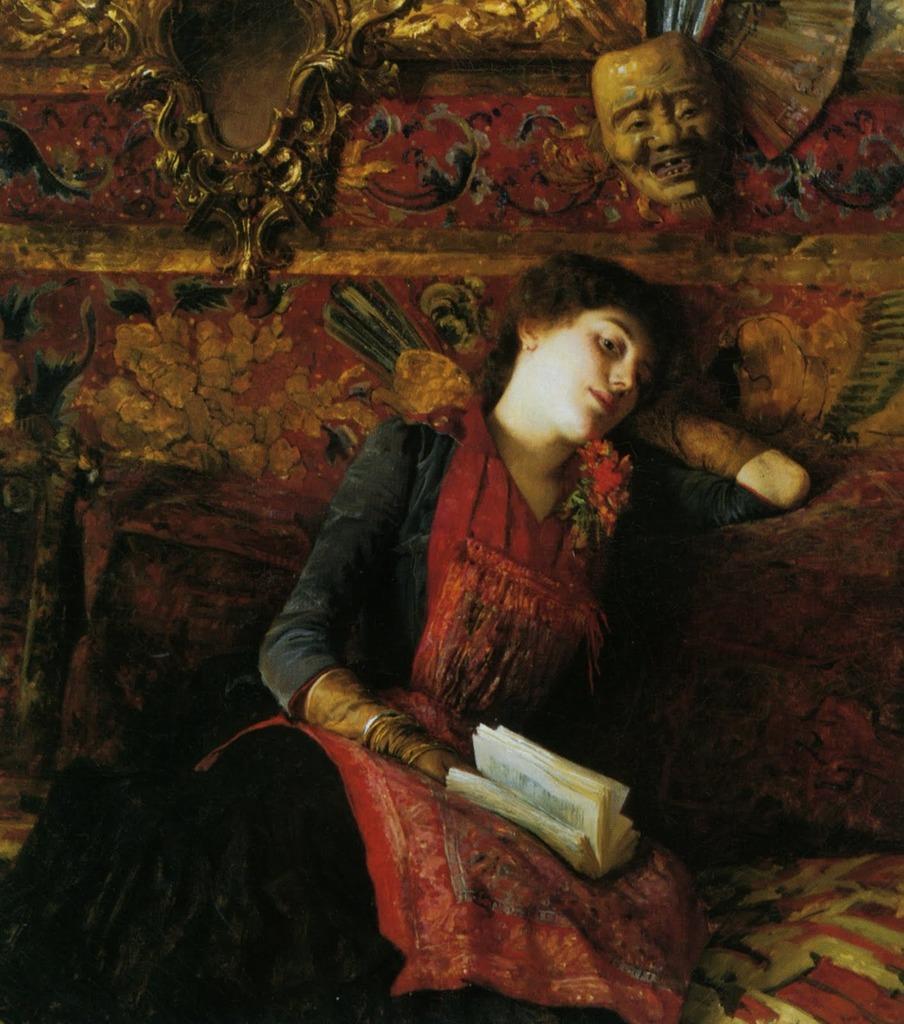Can you describe this image briefly? There is a girl sitting on the sofa laying her head on the backside of sofa and looking to some where holding a book in her hand. She is wearing a red dress. And there is a sculpture of a human head on the sofa. The sofa is in red colour too. There are pillows behind the woman. 